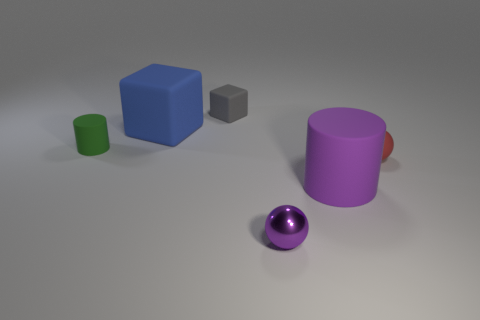Add 3 big gray matte objects. How many objects exist? 9 Subtract all cubes. How many objects are left? 4 Subtract 0 brown cubes. How many objects are left? 6 Subtract all metal things. Subtract all cylinders. How many objects are left? 3 Add 4 red things. How many red things are left? 5 Add 4 matte spheres. How many matte spheres exist? 5 